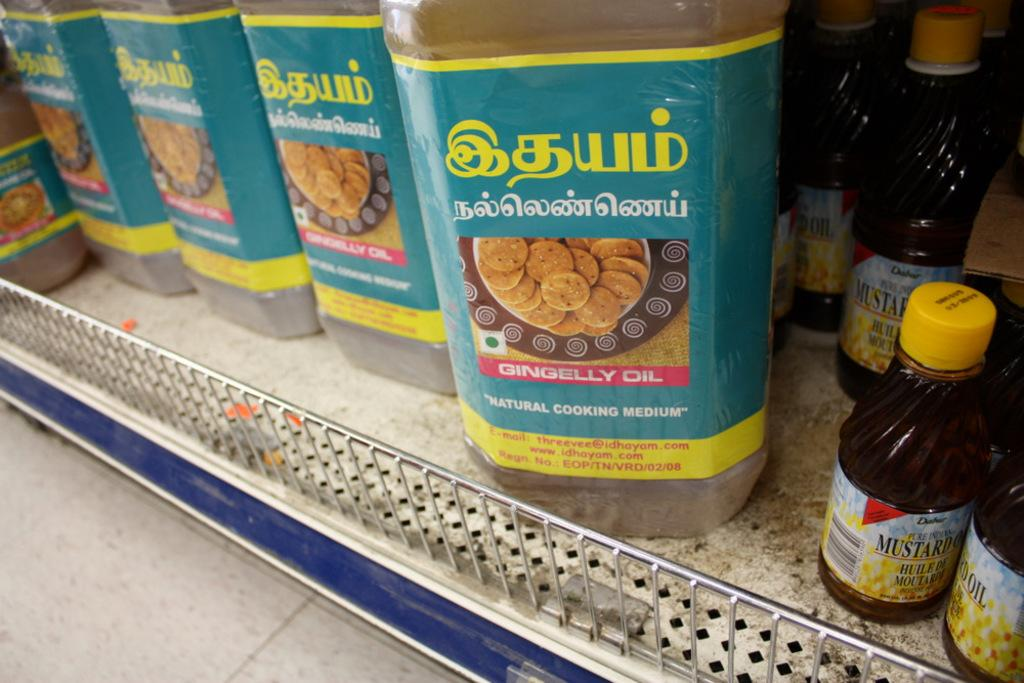What objects are present in the image? There are bottles in the image. Where are the bottles located? The bottles are placed on a surface. What page of the book is the bottle resting on in the image? There is no book present in the image, so the page cannot be determined. 